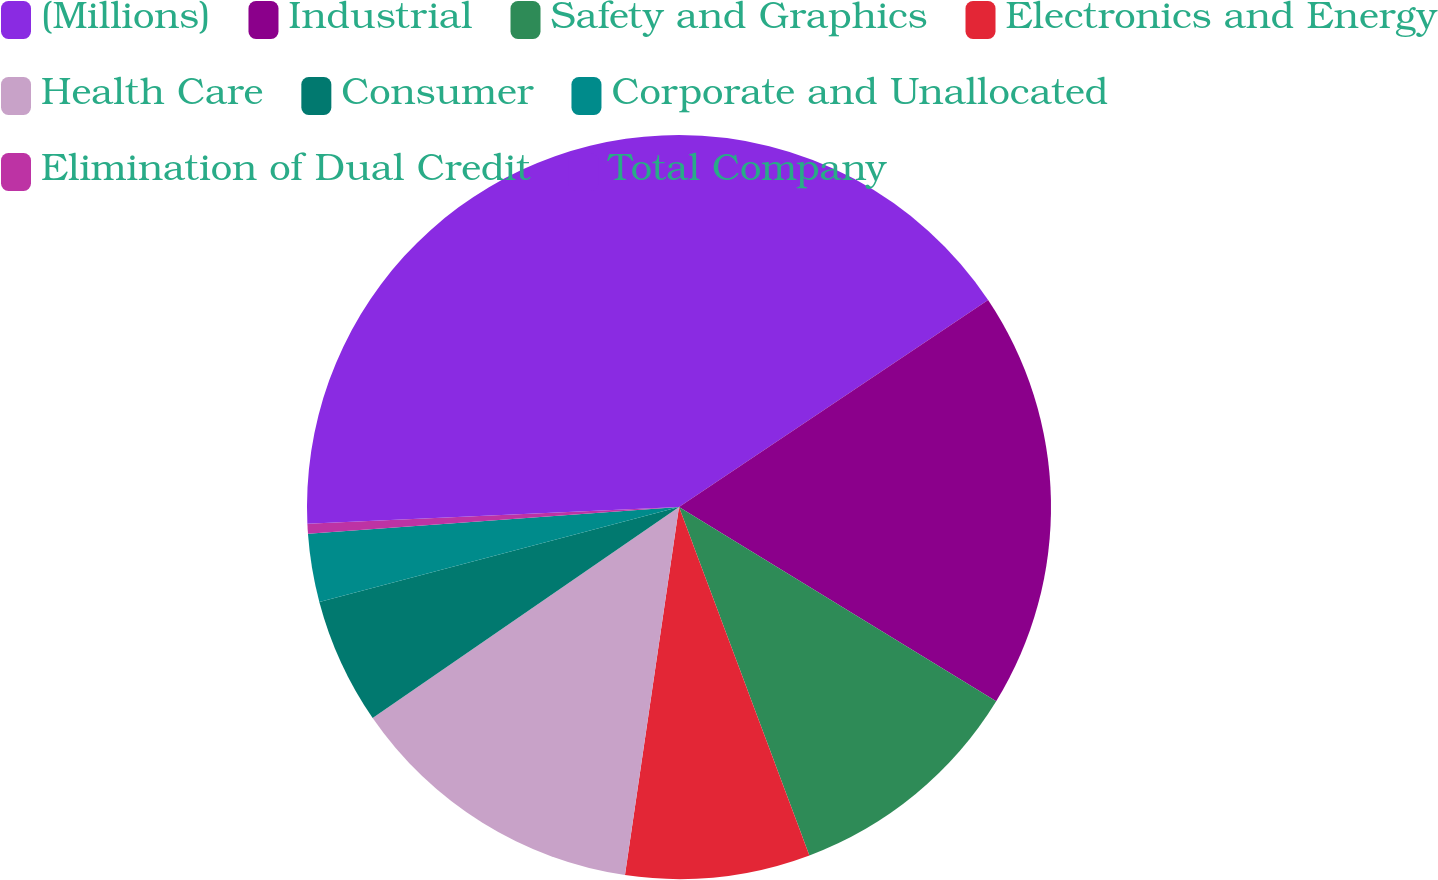Convert chart. <chart><loc_0><loc_0><loc_500><loc_500><pie_chart><fcel>(Millions)<fcel>Industrial<fcel>Safety and Graphics<fcel>Electronics and Energy<fcel>Health Care<fcel>Consumer<fcel>Corporate and Unallocated<fcel>Elimination of Dual Credit<fcel>Total Company<nl><fcel>15.61%<fcel>18.14%<fcel>10.55%<fcel>8.02%<fcel>13.08%<fcel>5.49%<fcel>2.96%<fcel>0.43%<fcel>25.72%<nl></chart> 